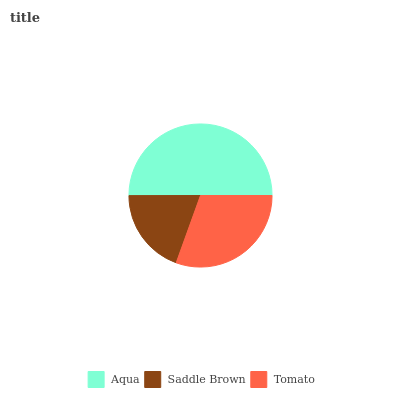Is Saddle Brown the minimum?
Answer yes or no. Yes. Is Aqua the maximum?
Answer yes or no. Yes. Is Tomato the minimum?
Answer yes or no. No. Is Tomato the maximum?
Answer yes or no. No. Is Tomato greater than Saddle Brown?
Answer yes or no. Yes. Is Saddle Brown less than Tomato?
Answer yes or no. Yes. Is Saddle Brown greater than Tomato?
Answer yes or no. No. Is Tomato less than Saddle Brown?
Answer yes or no. No. Is Tomato the high median?
Answer yes or no. Yes. Is Tomato the low median?
Answer yes or no. Yes. Is Saddle Brown the high median?
Answer yes or no. No. Is Saddle Brown the low median?
Answer yes or no. No. 